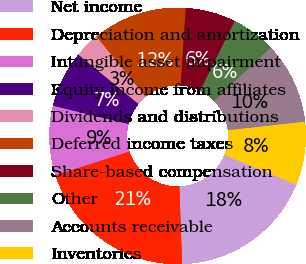Convert chart to OTSL. <chart><loc_0><loc_0><loc_500><loc_500><pie_chart><fcel>Net income<fcel>Depreciation and amortization<fcel>Intangible asset impairment<fcel>Equity income from affiliates<fcel>Dividends and distributions<fcel>Deferred income taxes<fcel>Share-based compensation<fcel>Other<fcel>Accounts receivable<fcel>Inventories<nl><fcel>18.25%<fcel>20.63%<fcel>8.73%<fcel>7.14%<fcel>3.18%<fcel>11.9%<fcel>6.35%<fcel>5.56%<fcel>10.32%<fcel>7.94%<nl></chart> 